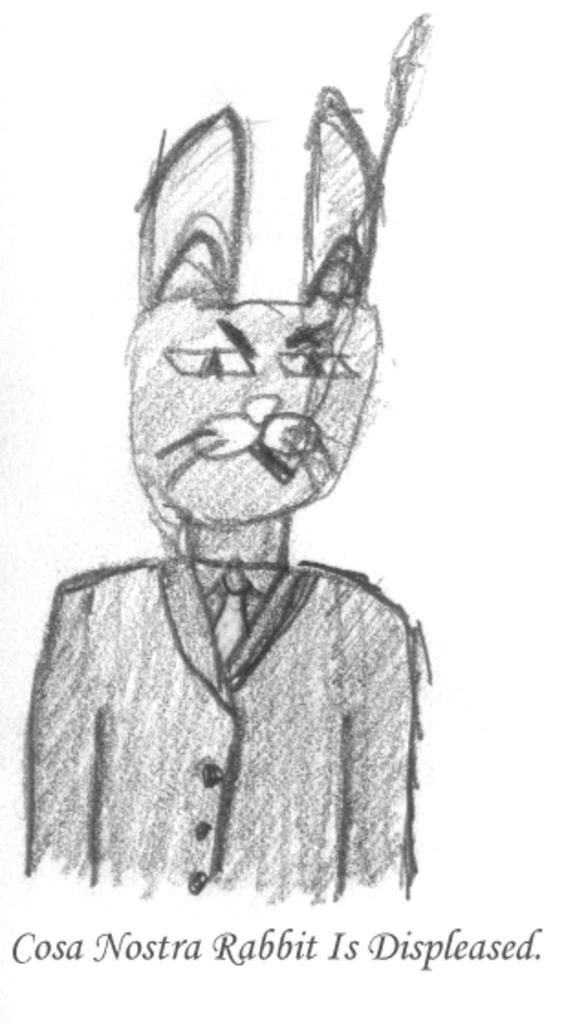What type of drawing is present in the image? There is a pencil sketch in the image. What else is featured in the image besides the pencil sketch? There is text in the image. What is the color of the background in the image? The background of the image is white in color. How does the pencil sketch start in the image? The pencil sketch does not start in the image; it is a static drawing. What type of body is depicted in the pencil sketch? There is no body depicted in the pencil sketch, as it is not a drawing of a person or an animal. 